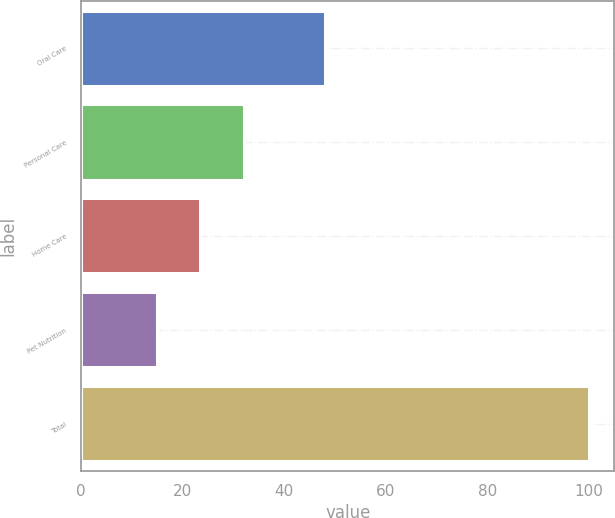Convert chart to OTSL. <chart><loc_0><loc_0><loc_500><loc_500><bar_chart><fcel>Oral Care<fcel>Personal Care<fcel>Home Care<fcel>Pet Nutrition<fcel>Total<nl><fcel>48<fcel>32<fcel>23.5<fcel>15<fcel>100<nl></chart> 